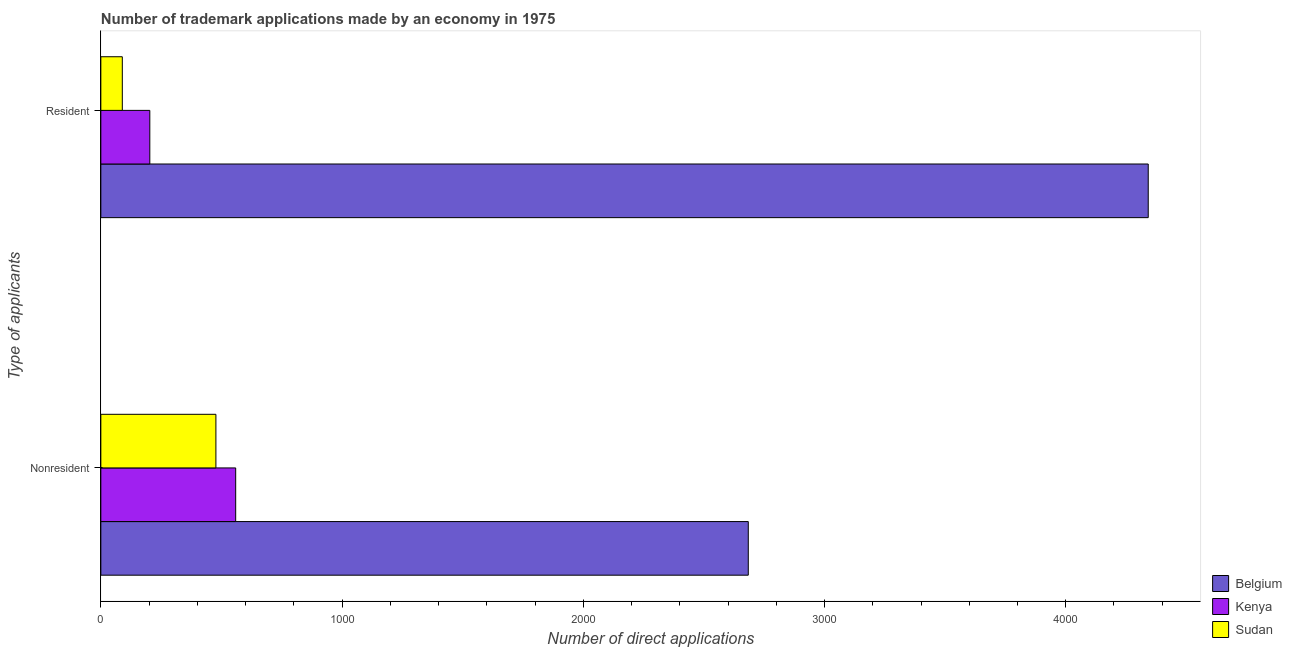Are the number of bars per tick equal to the number of legend labels?
Give a very brief answer. Yes. Are the number of bars on each tick of the Y-axis equal?
Provide a short and direct response. Yes. How many bars are there on the 2nd tick from the bottom?
Provide a succinct answer. 3. What is the label of the 1st group of bars from the top?
Provide a succinct answer. Resident. What is the number of trademark applications made by residents in Belgium?
Your answer should be very brief. 4342. Across all countries, what is the maximum number of trademark applications made by residents?
Ensure brevity in your answer.  4342. Across all countries, what is the minimum number of trademark applications made by non residents?
Your answer should be compact. 477. In which country was the number of trademark applications made by non residents minimum?
Offer a very short reply. Sudan. What is the total number of trademark applications made by non residents in the graph?
Your answer should be very brief. 3720. What is the difference between the number of trademark applications made by non residents in Belgium and that in Sudan?
Offer a terse response. 2207. What is the difference between the number of trademark applications made by non residents in Kenya and the number of trademark applications made by residents in Belgium?
Your response must be concise. -3783. What is the average number of trademark applications made by non residents per country?
Make the answer very short. 1240. What is the difference between the number of trademark applications made by non residents and number of trademark applications made by residents in Belgium?
Your answer should be very brief. -1658. In how many countries, is the number of trademark applications made by non residents greater than 200 ?
Keep it short and to the point. 3. What is the ratio of the number of trademark applications made by non residents in Kenya to that in Belgium?
Provide a succinct answer. 0.21. What does the 2nd bar from the top in Nonresident represents?
Your answer should be very brief. Kenya. What does the 2nd bar from the bottom in Nonresident represents?
Your response must be concise. Kenya. How many countries are there in the graph?
Your answer should be very brief. 3. What is the difference between two consecutive major ticks on the X-axis?
Provide a short and direct response. 1000. Does the graph contain any zero values?
Provide a succinct answer. No. Does the graph contain grids?
Your response must be concise. No. How many legend labels are there?
Your answer should be very brief. 3. What is the title of the graph?
Your answer should be compact. Number of trademark applications made by an economy in 1975. Does "Benin" appear as one of the legend labels in the graph?
Offer a terse response. No. What is the label or title of the X-axis?
Keep it short and to the point. Number of direct applications. What is the label or title of the Y-axis?
Ensure brevity in your answer.  Type of applicants. What is the Number of direct applications of Belgium in Nonresident?
Offer a very short reply. 2684. What is the Number of direct applications of Kenya in Nonresident?
Provide a short and direct response. 559. What is the Number of direct applications of Sudan in Nonresident?
Ensure brevity in your answer.  477. What is the Number of direct applications of Belgium in Resident?
Your answer should be very brief. 4342. What is the Number of direct applications of Kenya in Resident?
Give a very brief answer. 203. What is the Number of direct applications in Sudan in Resident?
Provide a succinct answer. 89. Across all Type of applicants, what is the maximum Number of direct applications of Belgium?
Give a very brief answer. 4342. Across all Type of applicants, what is the maximum Number of direct applications in Kenya?
Provide a short and direct response. 559. Across all Type of applicants, what is the maximum Number of direct applications in Sudan?
Make the answer very short. 477. Across all Type of applicants, what is the minimum Number of direct applications of Belgium?
Ensure brevity in your answer.  2684. Across all Type of applicants, what is the minimum Number of direct applications in Kenya?
Your answer should be compact. 203. Across all Type of applicants, what is the minimum Number of direct applications in Sudan?
Give a very brief answer. 89. What is the total Number of direct applications in Belgium in the graph?
Provide a short and direct response. 7026. What is the total Number of direct applications of Kenya in the graph?
Offer a terse response. 762. What is the total Number of direct applications of Sudan in the graph?
Ensure brevity in your answer.  566. What is the difference between the Number of direct applications of Belgium in Nonresident and that in Resident?
Provide a succinct answer. -1658. What is the difference between the Number of direct applications in Kenya in Nonresident and that in Resident?
Your response must be concise. 356. What is the difference between the Number of direct applications of Sudan in Nonresident and that in Resident?
Keep it short and to the point. 388. What is the difference between the Number of direct applications in Belgium in Nonresident and the Number of direct applications in Kenya in Resident?
Make the answer very short. 2481. What is the difference between the Number of direct applications in Belgium in Nonresident and the Number of direct applications in Sudan in Resident?
Provide a succinct answer. 2595. What is the difference between the Number of direct applications of Kenya in Nonresident and the Number of direct applications of Sudan in Resident?
Provide a succinct answer. 470. What is the average Number of direct applications of Belgium per Type of applicants?
Give a very brief answer. 3513. What is the average Number of direct applications of Kenya per Type of applicants?
Offer a terse response. 381. What is the average Number of direct applications of Sudan per Type of applicants?
Keep it short and to the point. 283. What is the difference between the Number of direct applications in Belgium and Number of direct applications in Kenya in Nonresident?
Provide a succinct answer. 2125. What is the difference between the Number of direct applications in Belgium and Number of direct applications in Sudan in Nonresident?
Your response must be concise. 2207. What is the difference between the Number of direct applications of Belgium and Number of direct applications of Kenya in Resident?
Your answer should be compact. 4139. What is the difference between the Number of direct applications in Belgium and Number of direct applications in Sudan in Resident?
Provide a succinct answer. 4253. What is the difference between the Number of direct applications of Kenya and Number of direct applications of Sudan in Resident?
Keep it short and to the point. 114. What is the ratio of the Number of direct applications in Belgium in Nonresident to that in Resident?
Give a very brief answer. 0.62. What is the ratio of the Number of direct applications in Kenya in Nonresident to that in Resident?
Provide a succinct answer. 2.75. What is the ratio of the Number of direct applications in Sudan in Nonresident to that in Resident?
Your answer should be compact. 5.36. What is the difference between the highest and the second highest Number of direct applications in Belgium?
Make the answer very short. 1658. What is the difference between the highest and the second highest Number of direct applications in Kenya?
Your response must be concise. 356. What is the difference between the highest and the second highest Number of direct applications of Sudan?
Ensure brevity in your answer.  388. What is the difference between the highest and the lowest Number of direct applications of Belgium?
Your answer should be compact. 1658. What is the difference between the highest and the lowest Number of direct applications in Kenya?
Keep it short and to the point. 356. What is the difference between the highest and the lowest Number of direct applications in Sudan?
Provide a short and direct response. 388. 